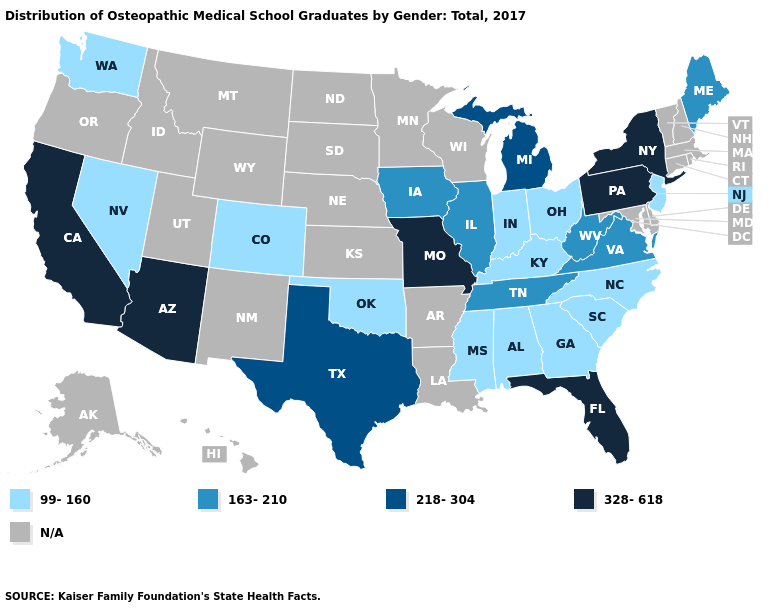Is the legend a continuous bar?
Give a very brief answer. No. What is the value of Montana?
Concise answer only. N/A. What is the highest value in states that border New Jersey?
Answer briefly. 328-618. Does California have the highest value in the USA?
Be succinct. Yes. Which states have the lowest value in the USA?
Concise answer only. Alabama, Colorado, Georgia, Indiana, Kentucky, Mississippi, Nevada, New Jersey, North Carolina, Ohio, Oklahoma, South Carolina, Washington. What is the lowest value in the USA?
Short answer required. 99-160. What is the highest value in states that border Oklahoma?
Give a very brief answer. 328-618. Name the states that have a value in the range 99-160?
Answer briefly. Alabama, Colorado, Georgia, Indiana, Kentucky, Mississippi, Nevada, New Jersey, North Carolina, Ohio, Oklahoma, South Carolina, Washington. What is the value of New York?
Be succinct. 328-618. What is the value of Montana?
Short answer required. N/A. What is the highest value in the West ?
Write a very short answer. 328-618. 